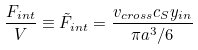<formula> <loc_0><loc_0><loc_500><loc_500>\frac { F _ { i n t } } { V } \equiv \tilde { F } _ { i n t } = \frac { v _ { c r o s s } c _ { S } y _ { i n } } { \pi a ^ { 3 } / 6 }</formula> 